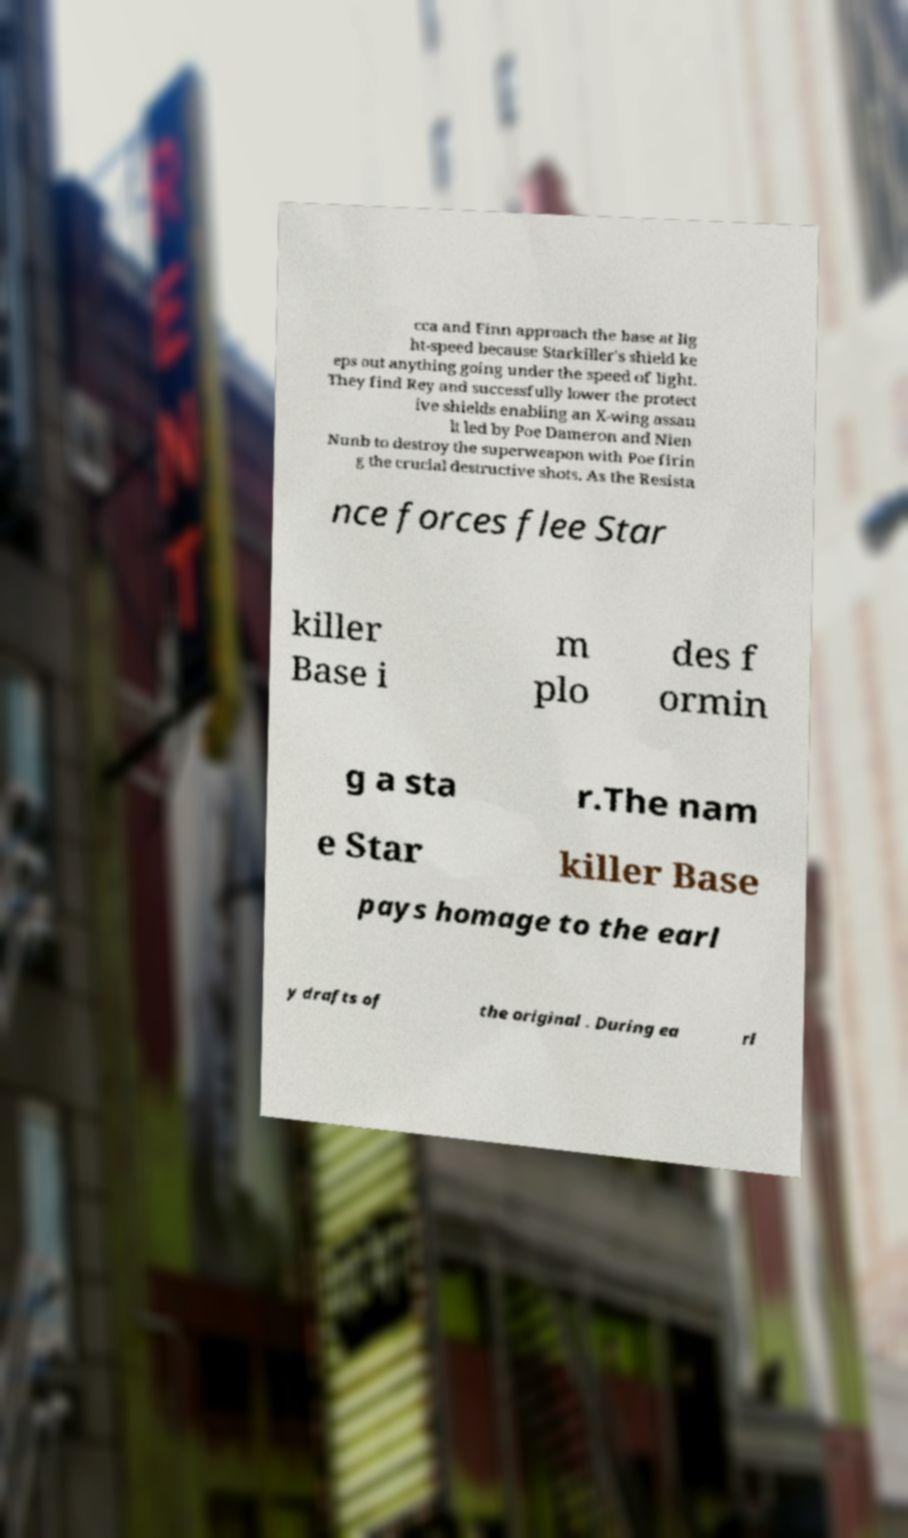For documentation purposes, I need the text within this image transcribed. Could you provide that? cca and Finn approach the base at lig ht-speed because Starkiller's shield ke eps out anything going under the speed of light. They find Rey and successfully lower the protect ive shields enabling an X-wing assau lt led by Poe Dameron and Nien Nunb to destroy the superweapon with Poe firin g the crucial destructive shots. As the Resista nce forces flee Star killer Base i m plo des f ormin g a sta r.The nam e Star killer Base pays homage to the earl y drafts of the original . During ea rl 